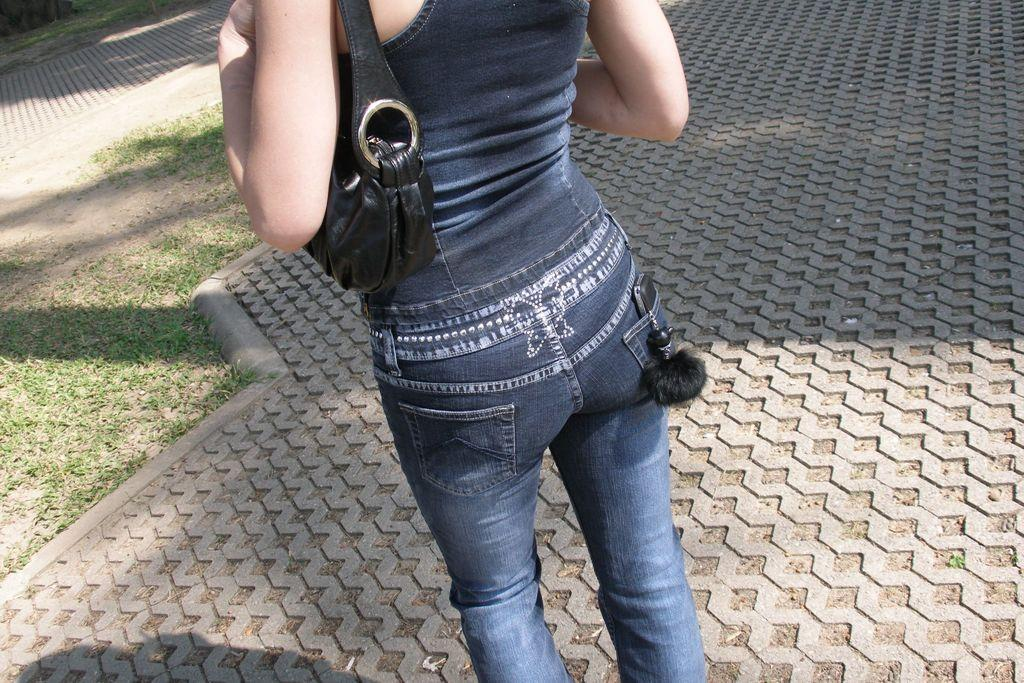Who is present in the image? There is a woman in the image. What is the woman standing on? The woman is standing on the pavement. What is the woman wearing on her upper body? The woman is wearing a dark blue top. What type of pants is the woman wearing? The woman is wearing jeans. What is the woman carrying in the image? The woman is carrying a black bag. What type of vegetation can be seen in the image? There is grass visible on the land. What type of nose does the woman have in the image? There is no information about the woman's nose in the image, so it cannot be determined. Is there a tent visible in the image? No, there is no tent present in the image. 